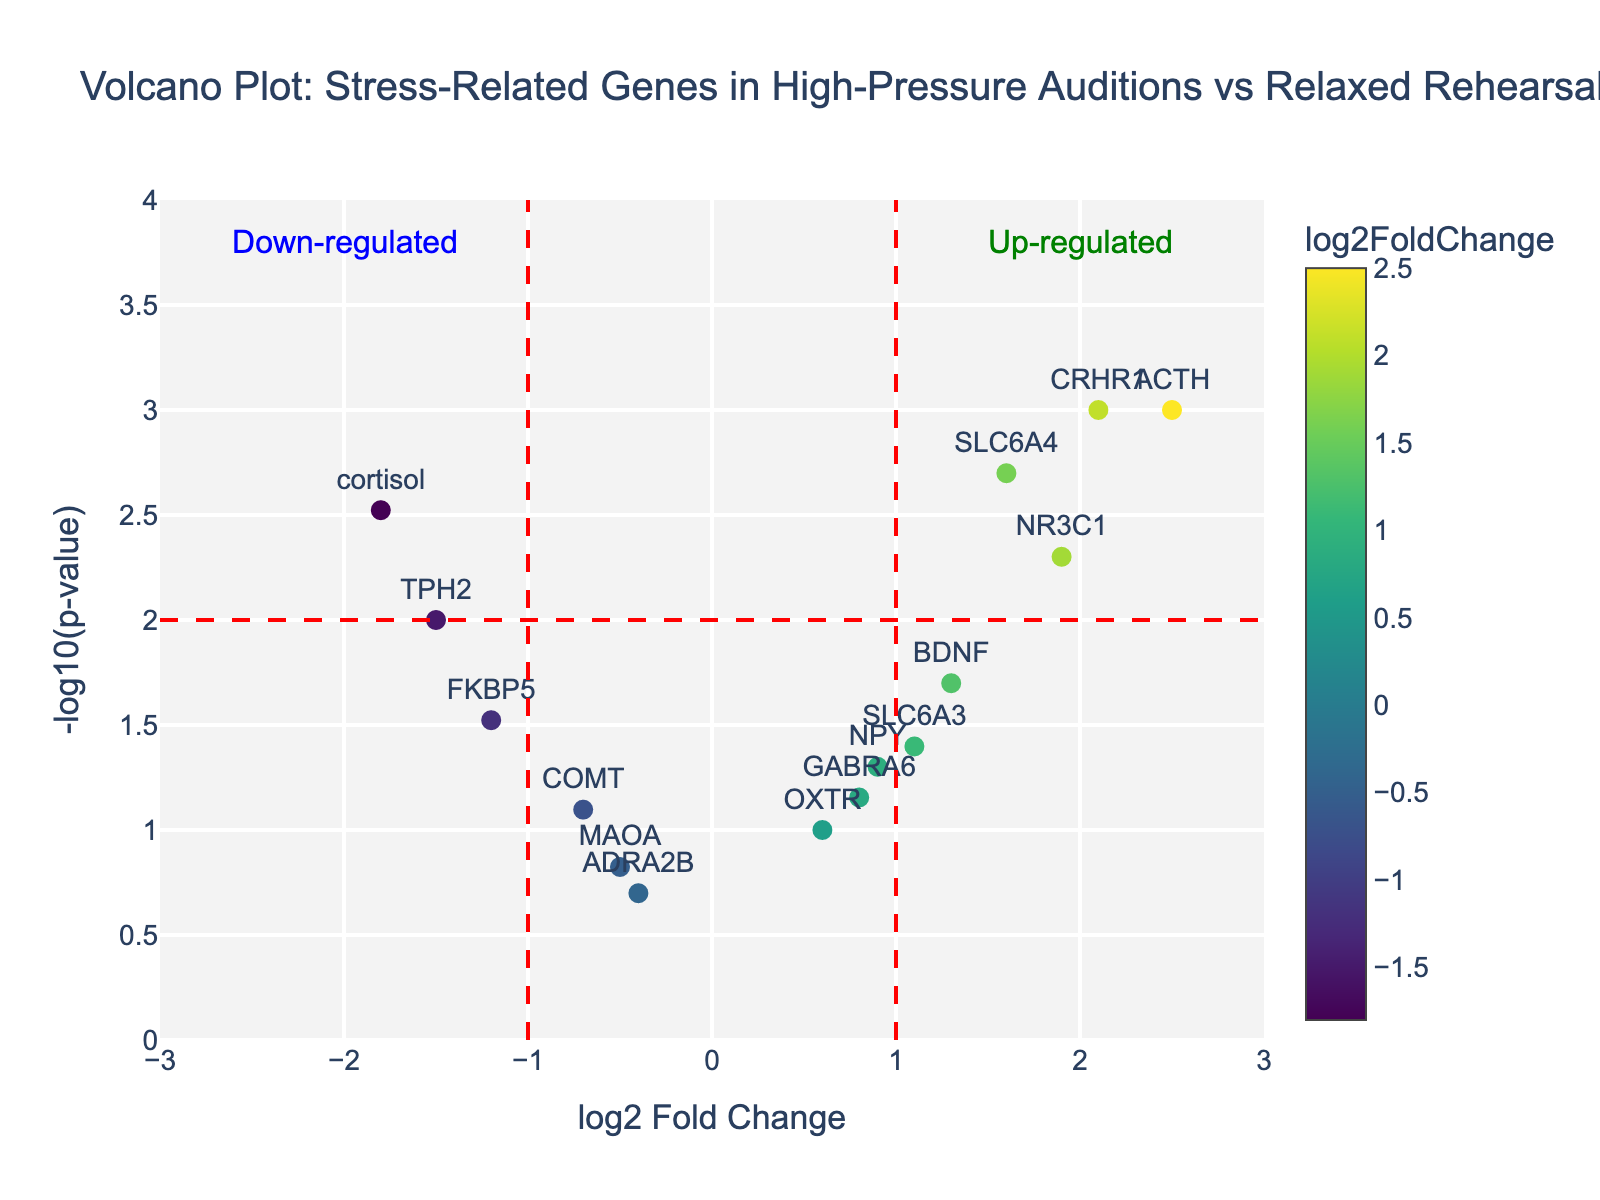What is the title of the plot? The title of the plot is usually displayed prominently at the top of the figure. It provides a summary of what the plot represents. In this case, it is "Volcano Plot: Stress-Related Genes in High-Pressure Auditions vs Relaxed Rehearsals"
Answer: Volcano Plot: Stress-Related Genes in High-Pressure Auditions vs Relaxed Rehearsals What are the axes labels? The axes labels give us information about what is plotted on each axis. The x-axis is labeled "log2 Fold Change," while the y-axis is labeled "-log10(p-value)."
Answer: log2 Fold Change (x-axis), -log10(p-value) (y-axis) How many genes have a log2FoldChange greater than 1? We count the number of genes that fall to the right of the vertical line marked at 1 on the x-axis. Looking at the plot, those genes are ACTH, SLC6A4, CRHR1, NR3C1.
Answer: 4 Which gene shows the highest level of down-regulation? Down-regulation is represented by a negative log2FoldChange. We look for the gene with the most negative log2FoldChange value. In this case, TPH2 has the lowest value at -1.5.
Answer: TPH2 What is the p-value threshold indicated in the plot? The p-value threshold is indicated by the horizontal red dashed line in the plot. This corresponds to -log10(p-value) = 2, which means the p-value threshold is 0.01 (since -log10(0.01) = 2).
Answer: 0.01 Which gene has the highest log2FoldChange and what is its p-value? We find the gene with the highest value on the x-axis (log2FoldChange) and look at its y-axis (p-value) value. ACTH has the highest log2FoldChange of 2.5 and its p-value is 0.001.
Answer: ACTH, 0.001 How many genes are significantly up-regulated? Genes are considered significantly up-regulated if they have a log2FoldChange greater than 1 and a p-value lower than 0.01 (corresponding to -log10(p-value) > 2). These genes are ACTH, SLC6A4, CRHR1, and NR3C1.
Answer: 4 Which gene is positioned closest to the horizontal axis? The gene closest to the horizontal axis has the smallest p-value but not necessarily is significant. OXTR is closest to the x-axis, around -log10(p-value) of 1 (p-value = 0.1).
Answer: OXTR 